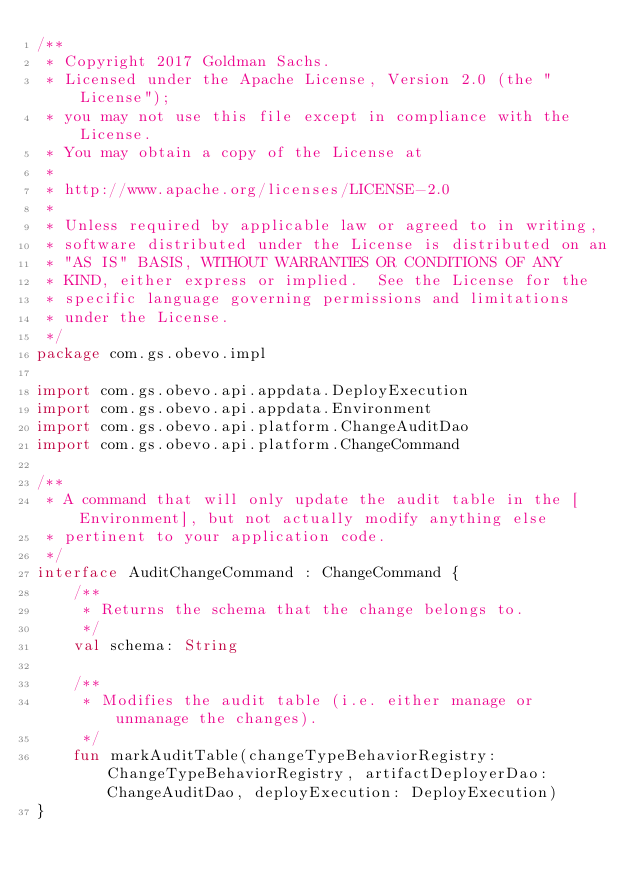Convert code to text. <code><loc_0><loc_0><loc_500><loc_500><_Kotlin_>/**
 * Copyright 2017 Goldman Sachs.
 * Licensed under the Apache License, Version 2.0 (the "License");
 * you may not use this file except in compliance with the License.
 * You may obtain a copy of the License at
 *
 * http://www.apache.org/licenses/LICENSE-2.0
 *
 * Unless required by applicable law or agreed to in writing,
 * software distributed under the License is distributed on an
 * "AS IS" BASIS, WITHOUT WARRANTIES OR CONDITIONS OF ANY
 * KIND, either express or implied.  See the License for the
 * specific language governing permissions and limitations
 * under the License.
 */
package com.gs.obevo.impl

import com.gs.obevo.api.appdata.DeployExecution
import com.gs.obevo.api.appdata.Environment
import com.gs.obevo.api.platform.ChangeAuditDao
import com.gs.obevo.api.platform.ChangeCommand

/**
 * A command that will only update the audit table in the [Environment], but not actually modify anything else
 * pertinent to your application code.
 */
interface AuditChangeCommand : ChangeCommand {
    /**
     * Returns the schema that the change belongs to.
     */
    val schema: String

    /**
     * Modifies the audit table (i.e. either manage or unmanage the changes).
     */
    fun markAuditTable(changeTypeBehaviorRegistry: ChangeTypeBehaviorRegistry, artifactDeployerDao: ChangeAuditDao, deployExecution: DeployExecution)
}
</code> 